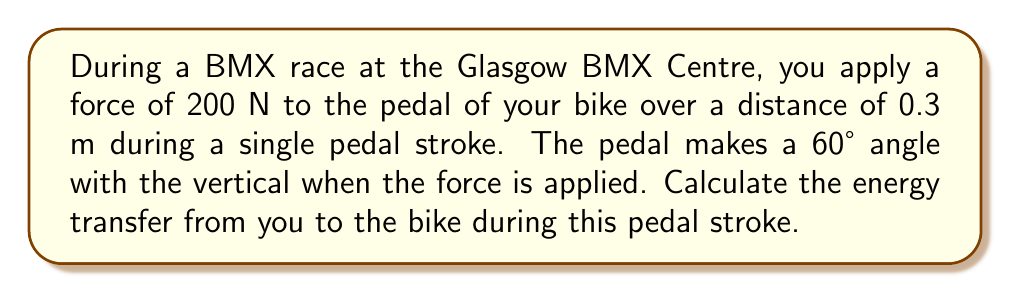Can you solve this math problem? To solve this problem, we need to follow these steps:

1. Determine the effective force:
   The force applied to the pedal is not entirely in the direction of motion. We need to find the component of the force that is parallel to the circular path of the pedal.

   $$F_{\text{effective}} = F \cos(30°)$$
   
   Note that we use 30° instead of 60° because we need the angle between the force and the tangent to the circular path, which is complementary to the given angle.

2. Calculate the work done:
   Work is defined as force multiplied by distance. In this case, we use the effective force.

   $$W = F_{\text{effective}} \cdot d$$

3. Energy transfer:
   The energy transferred from the rider to the bike is equal to the work done.

Let's plug in the values:

1. Effective force:
   $$F_{\text{effective}} = 200 \text{ N} \cdot \cos(30°) = 200 \text{ N} \cdot \frac{\sqrt{3}}{2} \approx 173.2 \text{ N}$$

2. Work done:
   $$W = 173.2 \text{ N} \cdot 0.3 \text{ m} = 51.96 \text{ J}$$

3. Energy transfer:
   The energy transferred is 51.96 J.
Answer: The energy transfer from the rider to the bike during the pedal stroke is approximately 51.96 J. 